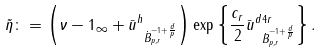Convert formula to latex. <formula><loc_0><loc_0><loc_500><loc_500>\tilde { \eta } \colon = \left ( \| \nu - 1 \| _ { \infty } + \| \bar { u } ^ { h } \| _ { \dot { B } _ { p , r } ^ { - 1 + \frac { d } { p } } } \right ) \exp \left \{ \frac { c _ { r } } { 2 } \| \bar { u } ^ { d } \| ^ { 4 r } _ { \dot { B } _ { p , r } ^ { - 1 + \frac { d } { p } } } \right \} .</formula> 